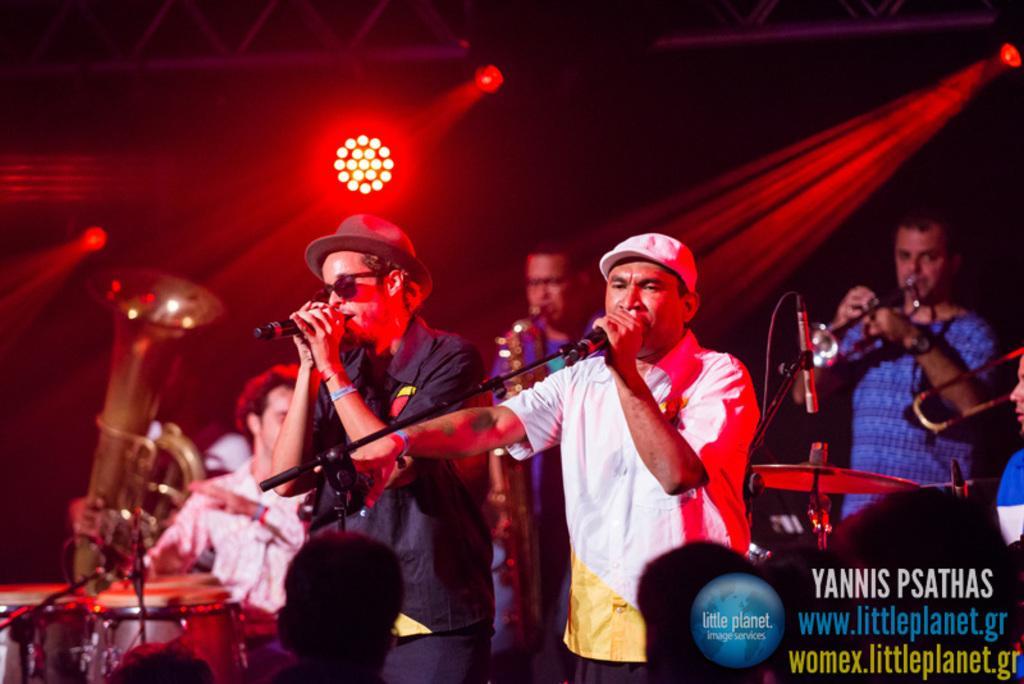Could you give a brief overview of what you see in this image? In this image there are a few people singing in a mic, behind them there are a few people playing some musical instruments, at the bottom of the image there is a logo and some text, in front of them there are a few people, in the background of the image there are focus lights and metal rods. 